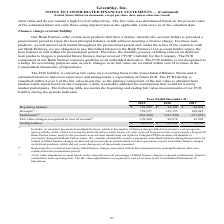According to Greensky's financial document, What does the amount of Settlements represent? the reversal of previously billed finance charges associated with deferred payment loan principal balances that were repaid within the promotional period.. The document states: "(2) Represents the reversal of previously billed finance charges associated with deferred payment loan principal balances that were repaid within the ..." Also, How was the fair value adjustment made for the fair value changes recognized in cost of revenue? based on the expected reversal percentage of billed finance charges (expected settlements), which is estimated at each reporting date.. The document states: "(3) A fair value adjustment is made based on the expected reversal percentage of billed finance charges (expected settlements), which is estimated at ..." Also, Which years does the table show? The document contains multiple relevant values: 2019, 2018, 2017. From the document: "Year Ended December 31, 2019 2018 2017 Beginning balance $ 138,589 $ 94,148 $ 68,064 Receipts (1) 159,527 129,153 109,818 Settlements (2) Year Ended D..." Also, How many years did the fair value changes exceed $100,000 thousand? Based on the analysis, there are 1 instances. The counting process: 2019. Also, can you calculate: What was the change in the settlements between 2017 and 2018? Based on the calculation: -181,590-(-127,029), the result is -54561 (in thousands). This is based on the information: ",153 109,818 Settlements (2) (262,449) (181,590) (127,029) Fair value changes recognized in cost of revenue (3) 170,368 96,878 43,295 Ending balance $ 206,03 59,527 129,153 109,818 Settlements (2) (26..." The key data points involved are: 127,029, 181,590. Also, can you calculate: What was the percentage change in the ending balance between 2018 and 2019? To answer this question, I need to perform calculations using the financial data. The calculation is: (206,035-138,589)/138,589, which equals 48.67 (percentage). This is based on the information: "evenue (3) 170,368 96,878 43,295 Ending balance $ 206,035 $ 138,589 $ 94,148 d December 31, 2019 2018 2017 Beginning balance $ 138,589 $ 94,148 $ 68,064 Receipts (1) 159,527 129,153 109,818 Settlement..." The key data points involved are: 138,589, 206,035. 